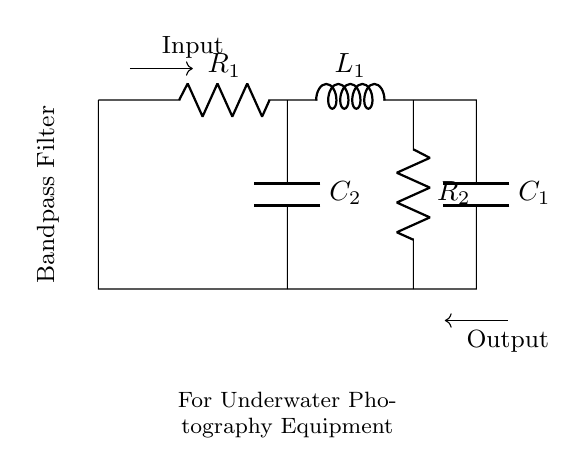What type of filter is this? The circuit diagram contains a combination of resistors, inductors, and capacitors arranged specifically to allow certain frequencies to pass while blocking others. This configuration indicates that it is a bandpass filter.
Answer: Bandpass Filter What components are present in this circuit? The circuit consists of two resistors, one inductor, and two capacitors. These components work together to filter specific frequency ranges.
Answer: Two resistors, one inductor, two capacitors What is the purpose of a bandpass filter? A bandpass filter is designed to isolate a specific range of frequencies by allowing them to pass through while attenuating frequencies outside of this range. This is particularly useful in applications like underwater photography to enhance certain imaging signals.
Answer: Isolate specific frequency ranges What are the values of the resistors in this circuit? The circuit diagram shows R1 and R2, which are labeled as resistors. However, without specific numerical values provided on the diagram, we cannot detail their resistances. They are simply referred to as R1 and R2.
Answer: R1, R2 How do capacitors affect the filter's frequency response? Capacitors in a bandpass filter influence the cutoff frequencies that determine which frequencies can pass through. They store and release energy, shaping the filter's response curve. The interplay with resistors and inductors sets the bandwidth.
Answer: Shape frequency response What's the connection type of the components? The components are connected in a specific sequence: resistors are in series with the inductor, and capacitors are arranged parallel to them. This connection type is crucial for the functioning of the filter.
Answer: Series and parallel connections What is the output of this circuit? The output of the circuit is taken after the bandpass filtering process has occurred, which means it delivers only the isolated frequency signals suitable for further processing in underwater photography.
Answer: Isolated frequency signals 